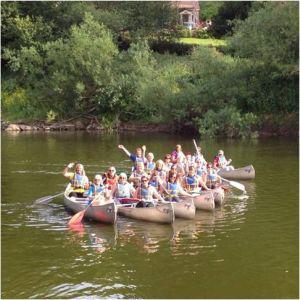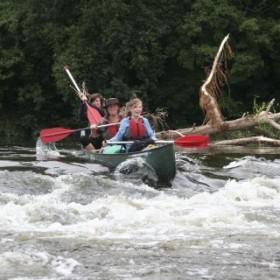The first image is the image on the left, the second image is the image on the right. Evaluate the accuracy of this statement regarding the images: "In at least one image there are a total three small boat.". Is it true? Answer yes or no. No. The first image is the image on the left, the second image is the image on the right. For the images displayed, is the sentence "The right image shows red oars." factually correct? Answer yes or no. Yes. 